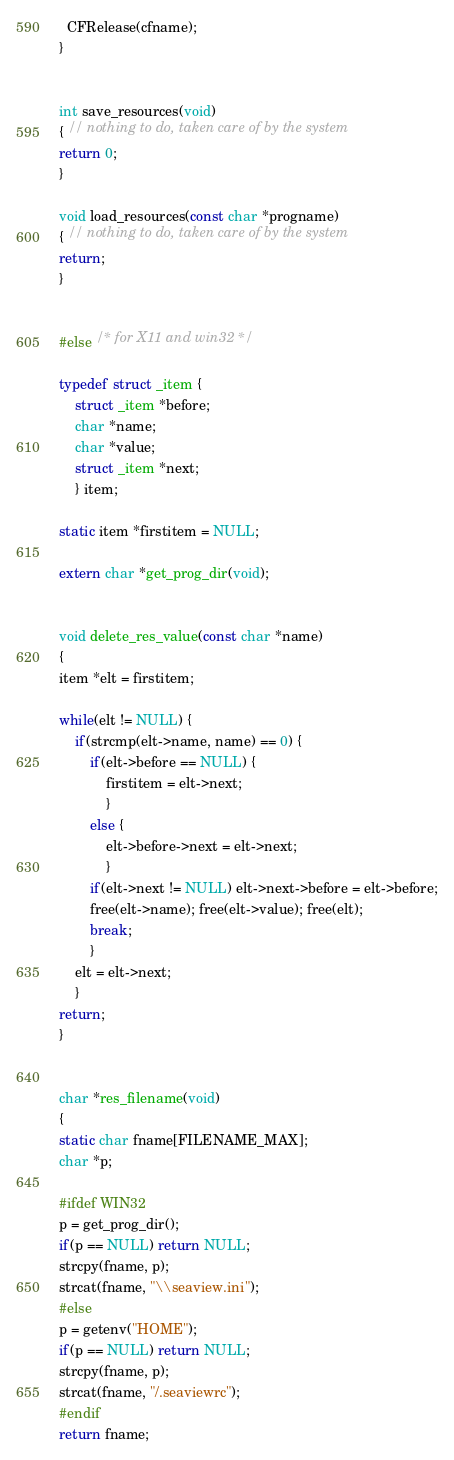<code> <loc_0><loc_0><loc_500><loc_500><_C++_>  CFRelease(cfname); 
}


int save_resources(void)
{ // nothing to do, taken care of by the system
return 0;
}

void load_resources(const char *progname)
{ // nothing to do, taken care of by the system
return;	
}


#else /* for X11 and win32 */

typedef struct _item {
	struct _item *before;
	char *name;
	char *value;
	struct _item *next;
	} item;

static item *firstitem = NULL;

extern char *get_prog_dir(void); 


void delete_res_value(const char *name)
{
item *elt = firstitem;

while(elt != NULL) {
	if(strcmp(elt->name, name) == 0) {
		if(elt->before == NULL) {
			firstitem = elt->next;
			}
		else {
			elt->before->next = elt->next;
			}
		if(elt->next != NULL) elt->next->before = elt->before;
		free(elt->name); free(elt->value); free(elt);
		break;
		}
	elt = elt->next;
	}
return;
}


char *res_filename(void)
{
static char fname[FILENAME_MAX];
char *p;

#ifdef WIN32
p = get_prog_dir();
if(p == NULL) return NULL;
strcpy(fname, p);
strcat(fname, "\\seaview.ini");
#else
p = getenv("HOME");
if(p == NULL) return NULL;
strcpy(fname, p);
strcat(fname, "/.seaviewrc");
#endif
return fname;</code> 